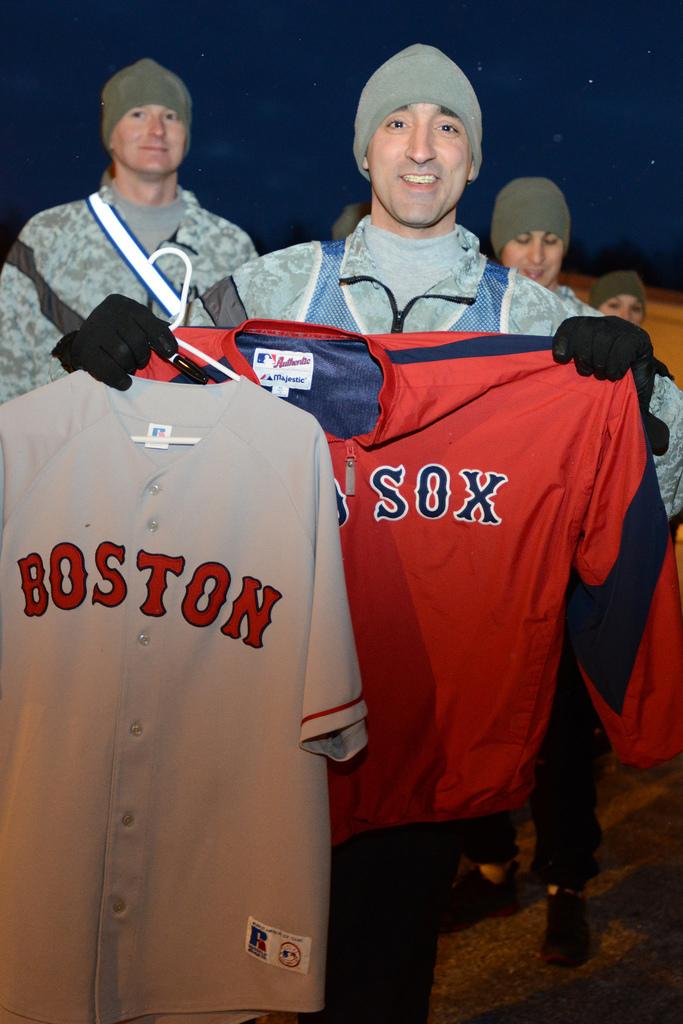What team is on the shirts?
Your answer should be very brief. Boston red sox. What city is on the gray shirt?
Give a very brief answer. Boston. 